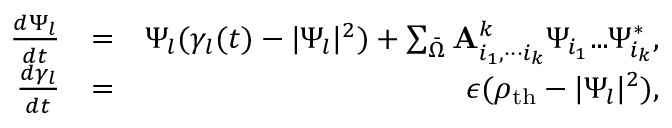<formula> <loc_0><loc_0><loc_500><loc_500>\begin{array} { r l r } { \frac { d \Psi _ { l } } { d t } } & { = } & { \Psi _ { l } ( \gamma _ { l } ( t ) - | \Psi _ { l } | ^ { 2 } ) + \sum _ { \bar { \Omega } } { A } _ { i _ { 1 } , { \cdot \cdot \cdot } i _ { k } } ^ { k } \Psi _ { i _ { 1 } } { \dots } \Psi _ { i _ { k } } ^ { * } , } \\ { \frac { d \gamma _ { l } } { d t } } & { = } & { \epsilon ( \rho _ { t h } - | \Psi _ { l } | ^ { 2 } ) , } \end{array}</formula> 